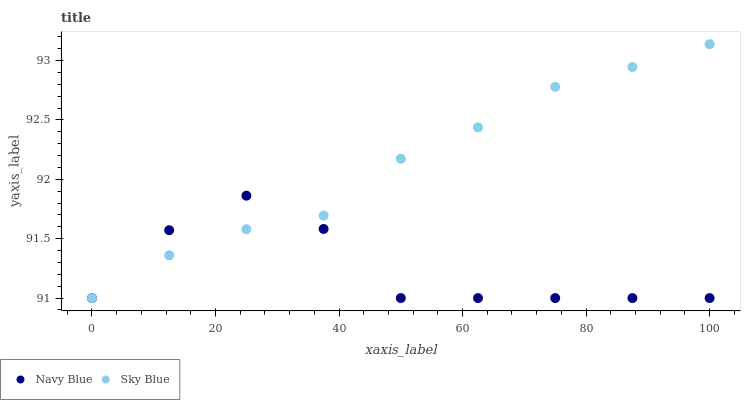Does Navy Blue have the minimum area under the curve?
Answer yes or no. Yes. Does Sky Blue have the maximum area under the curve?
Answer yes or no. Yes. Does Sky Blue have the minimum area under the curve?
Answer yes or no. No. Is Sky Blue the smoothest?
Answer yes or no. Yes. Is Navy Blue the roughest?
Answer yes or no. Yes. Is Sky Blue the roughest?
Answer yes or no. No. Does Navy Blue have the lowest value?
Answer yes or no. Yes. Does Sky Blue have the highest value?
Answer yes or no. Yes. Does Sky Blue intersect Navy Blue?
Answer yes or no. Yes. Is Sky Blue less than Navy Blue?
Answer yes or no. No. Is Sky Blue greater than Navy Blue?
Answer yes or no. No. 